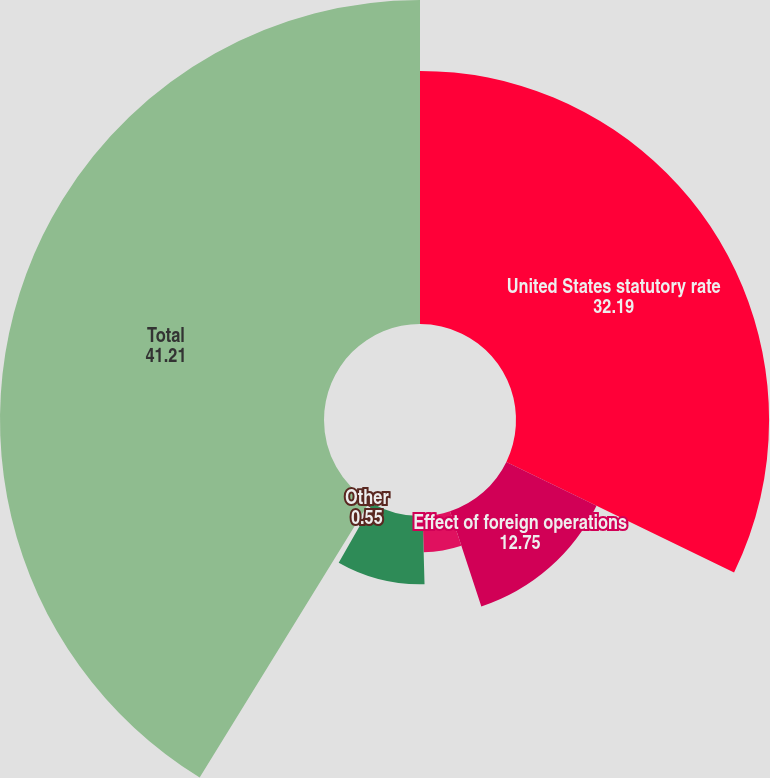<chart> <loc_0><loc_0><loc_500><loc_500><pie_chart><fcel>United States statutory rate<fcel>Effect of foreign operations<fcel>State income taxes net of<fcel>Gains on asset sales<fcel>Other<fcel>Total<nl><fcel>32.19%<fcel>12.75%<fcel>4.62%<fcel>8.68%<fcel>0.55%<fcel>41.21%<nl></chart> 